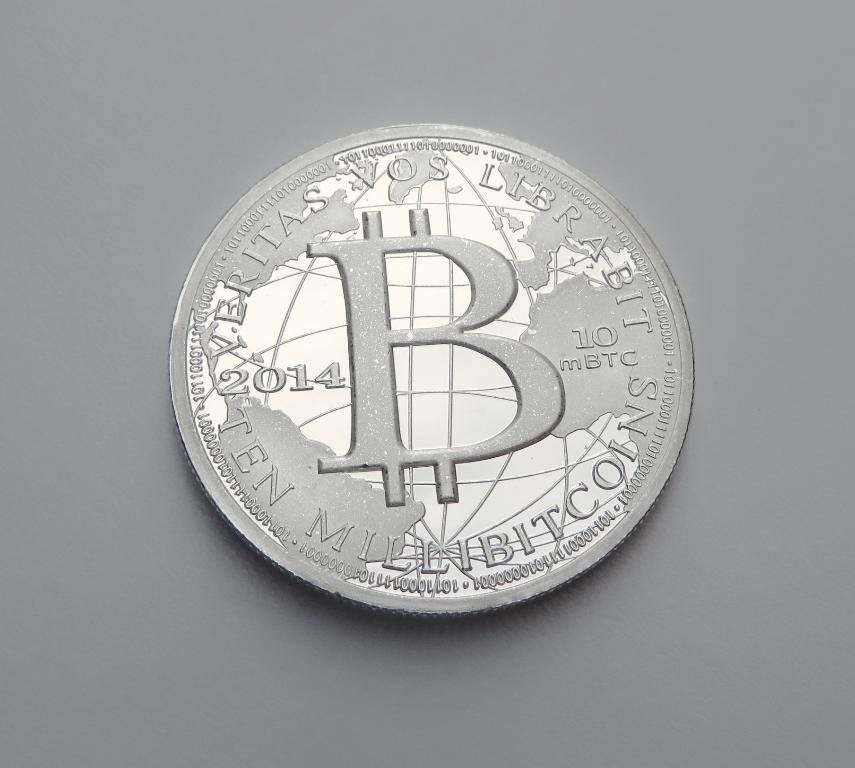Is this a bitcoin?
Give a very brief answer. Yes. What year is this?
Your answer should be very brief. 2014. 